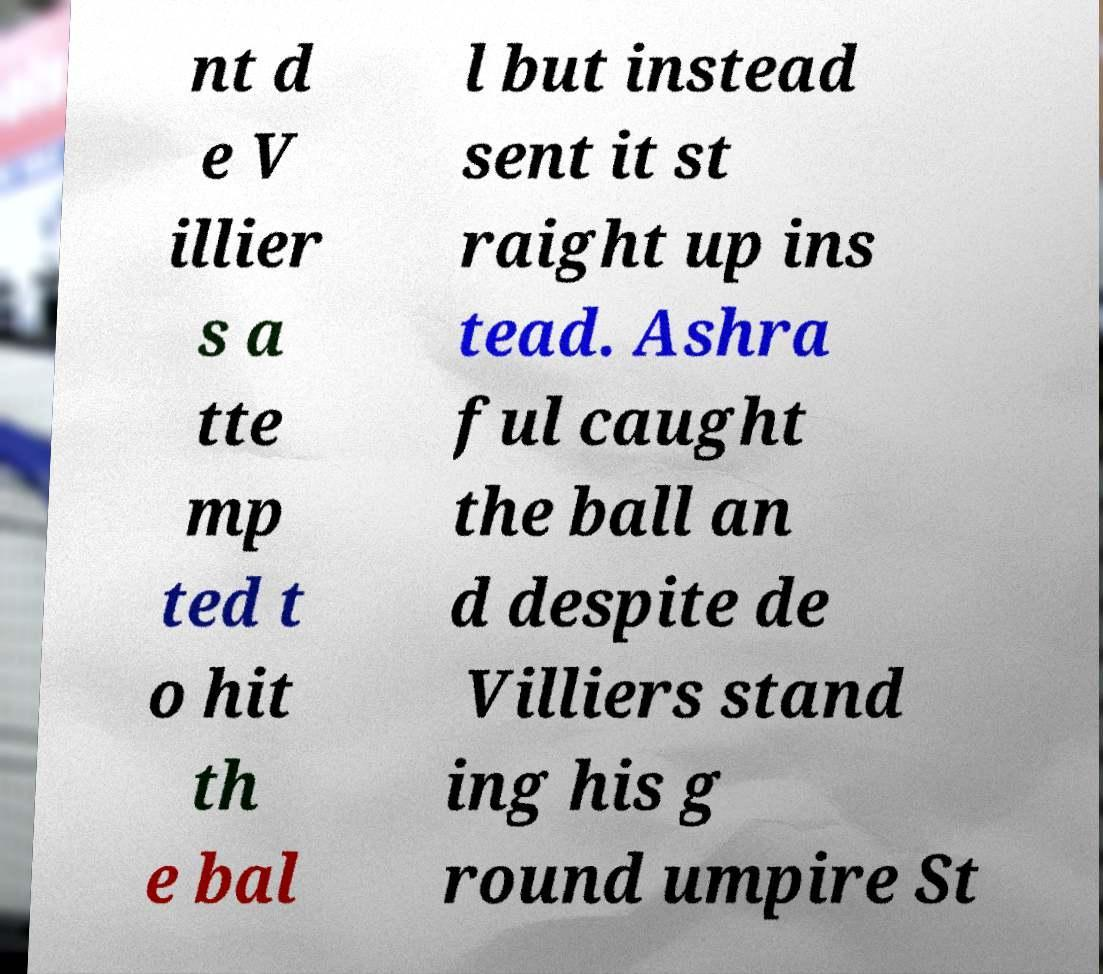Please read and relay the text visible in this image. What does it say? nt d e V illier s a tte mp ted t o hit th e bal l but instead sent it st raight up ins tead. Ashra ful caught the ball an d despite de Villiers stand ing his g round umpire St 